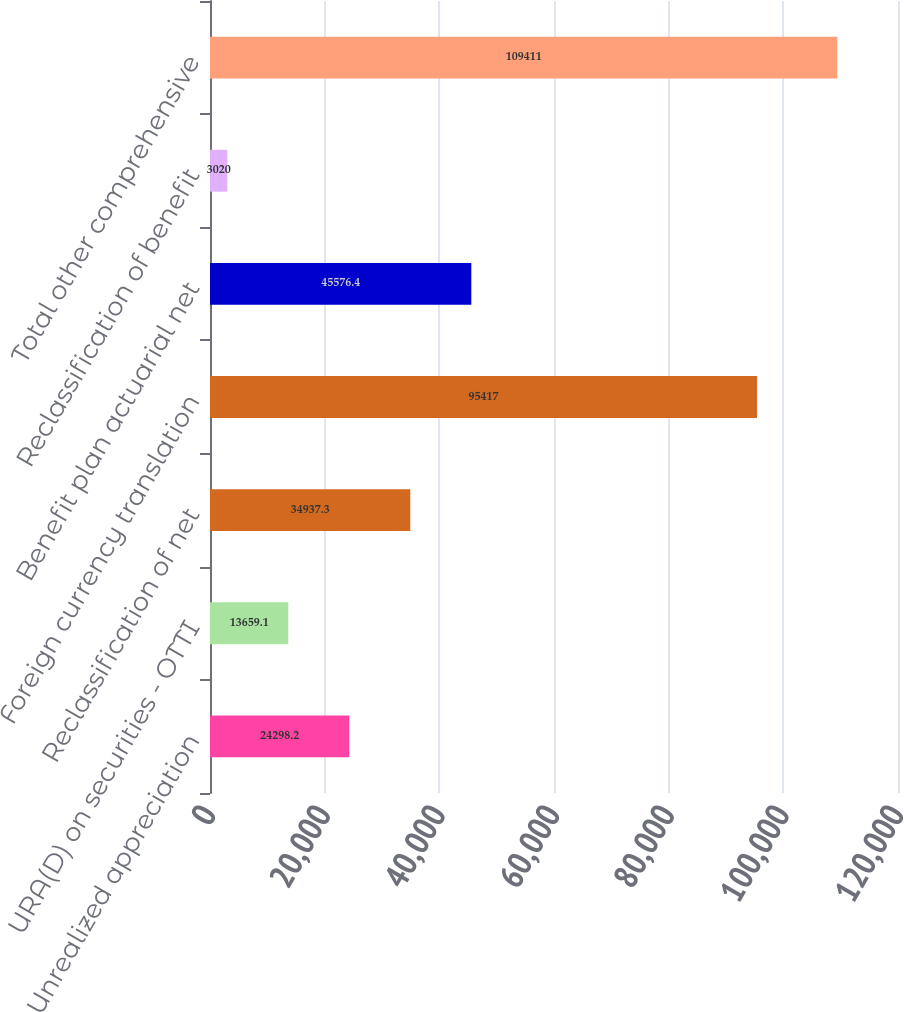Convert chart. <chart><loc_0><loc_0><loc_500><loc_500><bar_chart><fcel>Unrealized appreciation<fcel>URA(D) on securities - OTTI<fcel>Reclassification of net<fcel>Foreign currency translation<fcel>Benefit plan actuarial net<fcel>Reclassification of benefit<fcel>Total other comprehensive<nl><fcel>24298.2<fcel>13659.1<fcel>34937.3<fcel>95417<fcel>45576.4<fcel>3020<fcel>109411<nl></chart> 